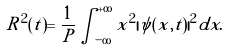Convert formula to latex. <formula><loc_0><loc_0><loc_500><loc_500>R ^ { 2 } ( t ) = \frac { 1 } { P } \int _ { - \infty } ^ { + \infty } x ^ { 2 } | \psi ( x , t ) | ^ { 2 } d x .</formula> 